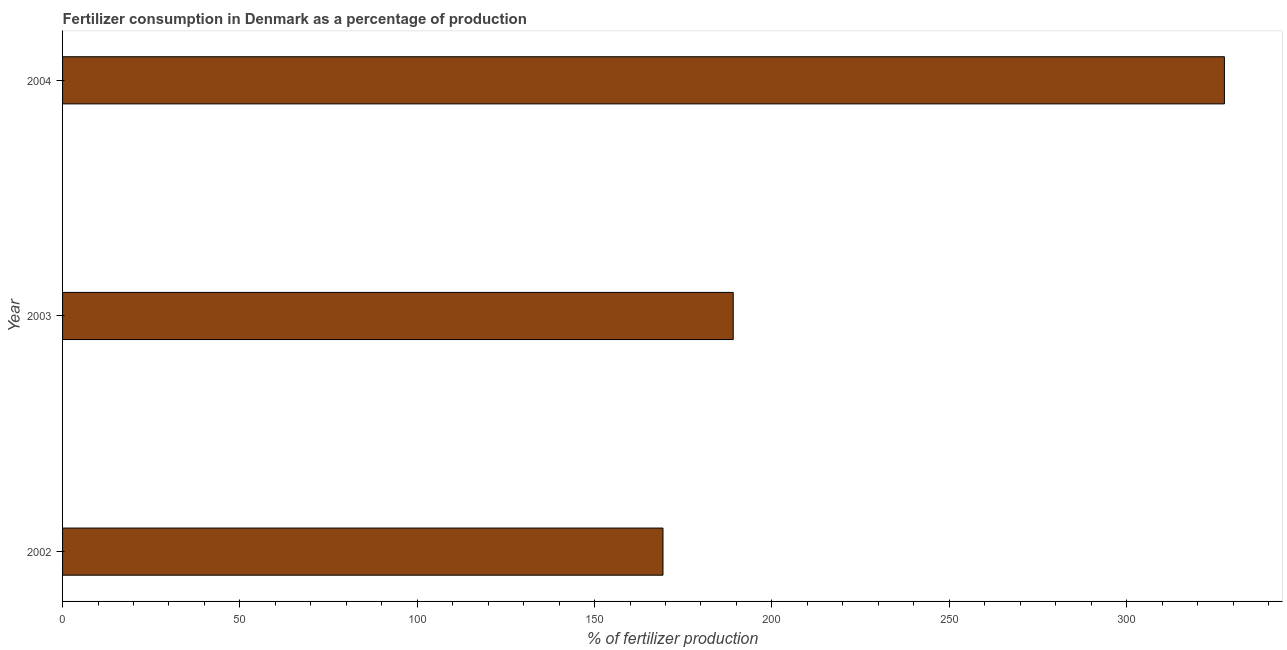Does the graph contain any zero values?
Your response must be concise. No. What is the title of the graph?
Provide a short and direct response. Fertilizer consumption in Denmark as a percentage of production. What is the label or title of the X-axis?
Provide a succinct answer. % of fertilizer production. What is the amount of fertilizer consumption in 2002?
Keep it short and to the point. 169.29. Across all years, what is the maximum amount of fertilizer consumption?
Offer a very short reply. 327.58. Across all years, what is the minimum amount of fertilizer consumption?
Ensure brevity in your answer.  169.29. In which year was the amount of fertilizer consumption minimum?
Your answer should be compact. 2002. What is the sum of the amount of fertilizer consumption?
Provide a succinct answer. 685.95. What is the difference between the amount of fertilizer consumption in 2003 and 2004?
Offer a terse response. -138.49. What is the average amount of fertilizer consumption per year?
Make the answer very short. 228.65. What is the median amount of fertilizer consumption?
Offer a terse response. 189.09. In how many years, is the amount of fertilizer consumption greater than 50 %?
Give a very brief answer. 3. Do a majority of the years between 2003 and 2004 (inclusive) have amount of fertilizer consumption greater than 50 %?
Keep it short and to the point. Yes. What is the ratio of the amount of fertilizer consumption in 2003 to that in 2004?
Your answer should be compact. 0.58. Is the difference between the amount of fertilizer consumption in 2002 and 2004 greater than the difference between any two years?
Provide a short and direct response. Yes. What is the difference between the highest and the second highest amount of fertilizer consumption?
Give a very brief answer. 138.49. Is the sum of the amount of fertilizer consumption in 2003 and 2004 greater than the maximum amount of fertilizer consumption across all years?
Offer a very short reply. Yes. What is the difference between the highest and the lowest amount of fertilizer consumption?
Your answer should be compact. 158.29. In how many years, is the amount of fertilizer consumption greater than the average amount of fertilizer consumption taken over all years?
Your answer should be very brief. 1. Are all the bars in the graph horizontal?
Offer a very short reply. Yes. What is the % of fertilizer production of 2002?
Keep it short and to the point. 169.29. What is the % of fertilizer production of 2003?
Give a very brief answer. 189.09. What is the % of fertilizer production of 2004?
Offer a terse response. 327.58. What is the difference between the % of fertilizer production in 2002 and 2003?
Provide a succinct answer. -19.8. What is the difference between the % of fertilizer production in 2002 and 2004?
Provide a short and direct response. -158.29. What is the difference between the % of fertilizer production in 2003 and 2004?
Offer a terse response. -138.49. What is the ratio of the % of fertilizer production in 2002 to that in 2003?
Your response must be concise. 0.9. What is the ratio of the % of fertilizer production in 2002 to that in 2004?
Ensure brevity in your answer.  0.52. What is the ratio of the % of fertilizer production in 2003 to that in 2004?
Offer a terse response. 0.58. 